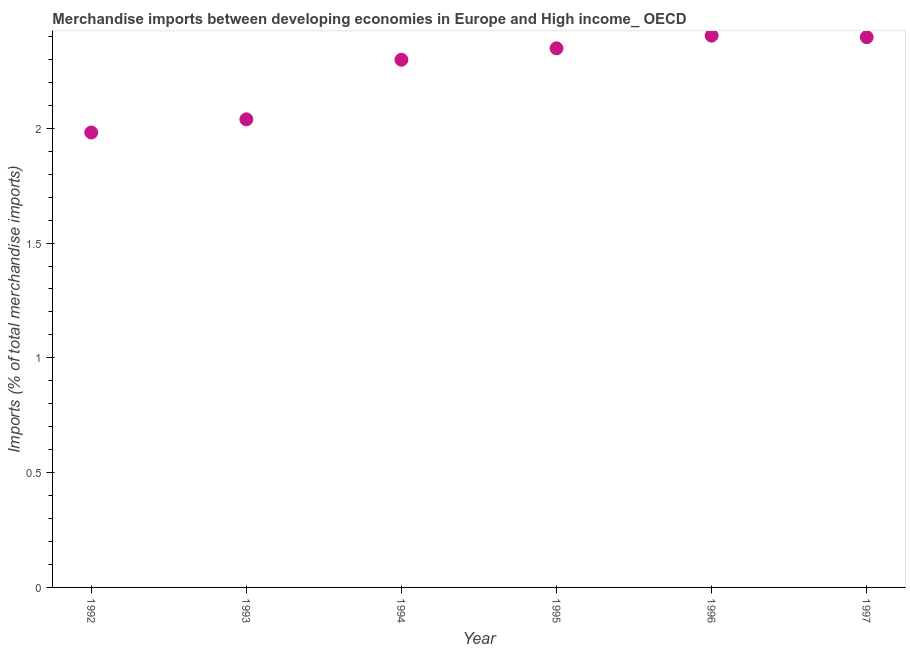What is the merchandise imports in 1995?
Give a very brief answer. 2.35. Across all years, what is the maximum merchandise imports?
Make the answer very short. 2.4. Across all years, what is the minimum merchandise imports?
Your response must be concise. 1.98. In which year was the merchandise imports maximum?
Keep it short and to the point. 1996. What is the sum of the merchandise imports?
Offer a very short reply. 13.47. What is the difference between the merchandise imports in 1992 and 1994?
Your response must be concise. -0.32. What is the average merchandise imports per year?
Provide a short and direct response. 2.24. What is the median merchandise imports?
Ensure brevity in your answer.  2.32. In how many years, is the merchandise imports greater than 1.5 %?
Your answer should be very brief. 6. Do a majority of the years between 1995 and 1996 (inclusive) have merchandise imports greater than 1.6 %?
Your response must be concise. Yes. What is the ratio of the merchandise imports in 1992 to that in 1997?
Offer a very short reply. 0.83. Is the merchandise imports in 1992 less than that in 1995?
Your answer should be compact. Yes. What is the difference between the highest and the second highest merchandise imports?
Your answer should be compact. 0.01. What is the difference between the highest and the lowest merchandise imports?
Your answer should be compact. 0.42. How many dotlines are there?
Ensure brevity in your answer.  1. What is the difference between two consecutive major ticks on the Y-axis?
Offer a terse response. 0.5. Are the values on the major ticks of Y-axis written in scientific E-notation?
Your response must be concise. No. Does the graph contain any zero values?
Offer a terse response. No. What is the title of the graph?
Your response must be concise. Merchandise imports between developing economies in Europe and High income_ OECD. What is the label or title of the X-axis?
Make the answer very short. Year. What is the label or title of the Y-axis?
Provide a succinct answer. Imports (% of total merchandise imports). What is the Imports (% of total merchandise imports) in 1992?
Your answer should be compact. 1.98. What is the Imports (% of total merchandise imports) in 1993?
Offer a very short reply. 2.04. What is the Imports (% of total merchandise imports) in 1994?
Provide a short and direct response. 2.3. What is the Imports (% of total merchandise imports) in 1995?
Keep it short and to the point. 2.35. What is the Imports (% of total merchandise imports) in 1996?
Make the answer very short. 2.4. What is the Imports (% of total merchandise imports) in 1997?
Ensure brevity in your answer.  2.4. What is the difference between the Imports (% of total merchandise imports) in 1992 and 1993?
Make the answer very short. -0.06. What is the difference between the Imports (% of total merchandise imports) in 1992 and 1994?
Your response must be concise. -0.32. What is the difference between the Imports (% of total merchandise imports) in 1992 and 1995?
Provide a short and direct response. -0.37. What is the difference between the Imports (% of total merchandise imports) in 1992 and 1996?
Provide a short and direct response. -0.42. What is the difference between the Imports (% of total merchandise imports) in 1992 and 1997?
Give a very brief answer. -0.42. What is the difference between the Imports (% of total merchandise imports) in 1993 and 1994?
Your answer should be very brief. -0.26. What is the difference between the Imports (% of total merchandise imports) in 1993 and 1995?
Your response must be concise. -0.31. What is the difference between the Imports (% of total merchandise imports) in 1993 and 1996?
Your answer should be very brief. -0.36. What is the difference between the Imports (% of total merchandise imports) in 1993 and 1997?
Your answer should be compact. -0.36. What is the difference between the Imports (% of total merchandise imports) in 1994 and 1995?
Provide a succinct answer. -0.05. What is the difference between the Imports (% of total merchandise imports) in 1994 and 1996?
Provide a short and direct response. -0.1. What is the difference between the Imports (% of total merchandise imports) in 1994 and 1997?
Offer a terse response. -0.1. What is the difference between the Imports (% of total merchandise imports) in 1995 and 1996?
Make the answer very short. -0.06. What is the difference between the Imports (% of total merchandise imports) in 1995 and 1997?
Provide a succinct answer. -0.05. What is the difference between the Imports (% of total merchandise imports) in 1996 and 1997?
Your answer should be compact. 0.01. What is the ratio of the Imports (% of total merchandise imports) in 1992 to that in 1994?
Provide a succinct answer. 0.86. What is the ratio of the Imports (% of total merchandise imports) in 1992 to that in 1995?
Offer a terse response. 0.84. What is the ratio of the Imports (% of total merchandise imports) in 1992 to that in 1996?
Keep it short and to the point. 0.82. What is the ratio of the Imports (% of total merchandise imports) in 1992 to that in 1997?
Provide a short and direct response. 0.83. What is the ratio of the Imports (% of total merchandise imports) in 1993 to that in 1994?
Your answer should be very brief. 0.89. What is the ratio of the Imports (% of total merchandise imports) in 1993 to that in 1995?
Your answer should be very brief. 0.87. What is the ratio of the Imports (% of total merchandise imports) in 1993 to that in 1996?
Make the answer very short. 0.85. What is the ratio of the Imports (% of total merchandise imports) in 1993 to that in 1997?
Ensure brevity in your answer.  0.85. What is the ratio of the Imports (% of total merchandise imports) in 1994 to that in 1995?
Offer a terse response. 0.98. What is the ratio of the Imports (% of total merchandise imports) in 1994 to that in 1996?
Ensure brevity in your answer.  0.96. What is the ratio of the Imports (% of total merchandise imports) in 1994 to that in 1997?
Provide a short and direct response. 0.96. What is the ratio of the Imports (% of total merchandise imports) in 1995 to that in 1996?
Offer a terse response. 0.98. What is the ratio of the Imports (% of total merchandise imports) in 1995 to that in 1997?
Your answer should be very brief. 0.98. 